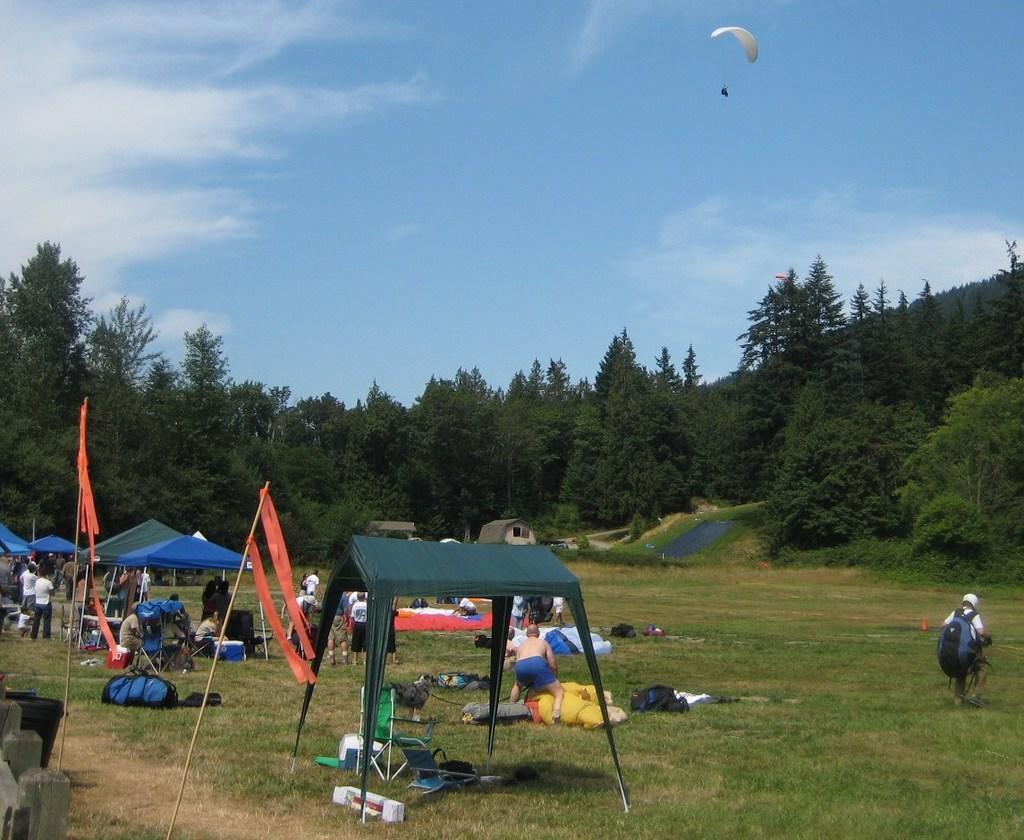Could you give a brief overview of what you see in this image? This picture shows trees and a blue cloudy sky and we see a human flying with the help of a parachute and we see few tents and few bags and clothes on the ground. We see a chair and we see few people standing and a man wore a bag on his back. 